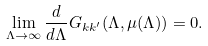Convert formula to latex. <formula><loc_0><loc_0><loc_500><loc_500>\lim _ { \Lambda \to \infty } \frac { d } { d \Lambda } G _ { k k ^ { \prime } } ( \Lambda , \mu ( \Lambda ) ) = 0 .</formula> 